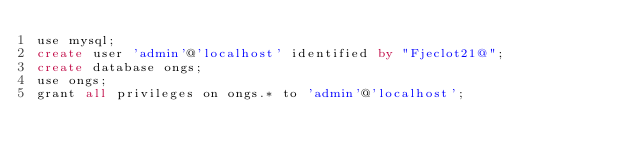Convert code to text. <code><loc_0><loc_0><loc_500><loc_500><_SQL_>use mysql;
create user 'admin'@'localhost' identified by "Fjeclot21@";
create database ongs;
use ongs;
grant all privileges on ongs.* to 'admin'@'localhost';


</code> 